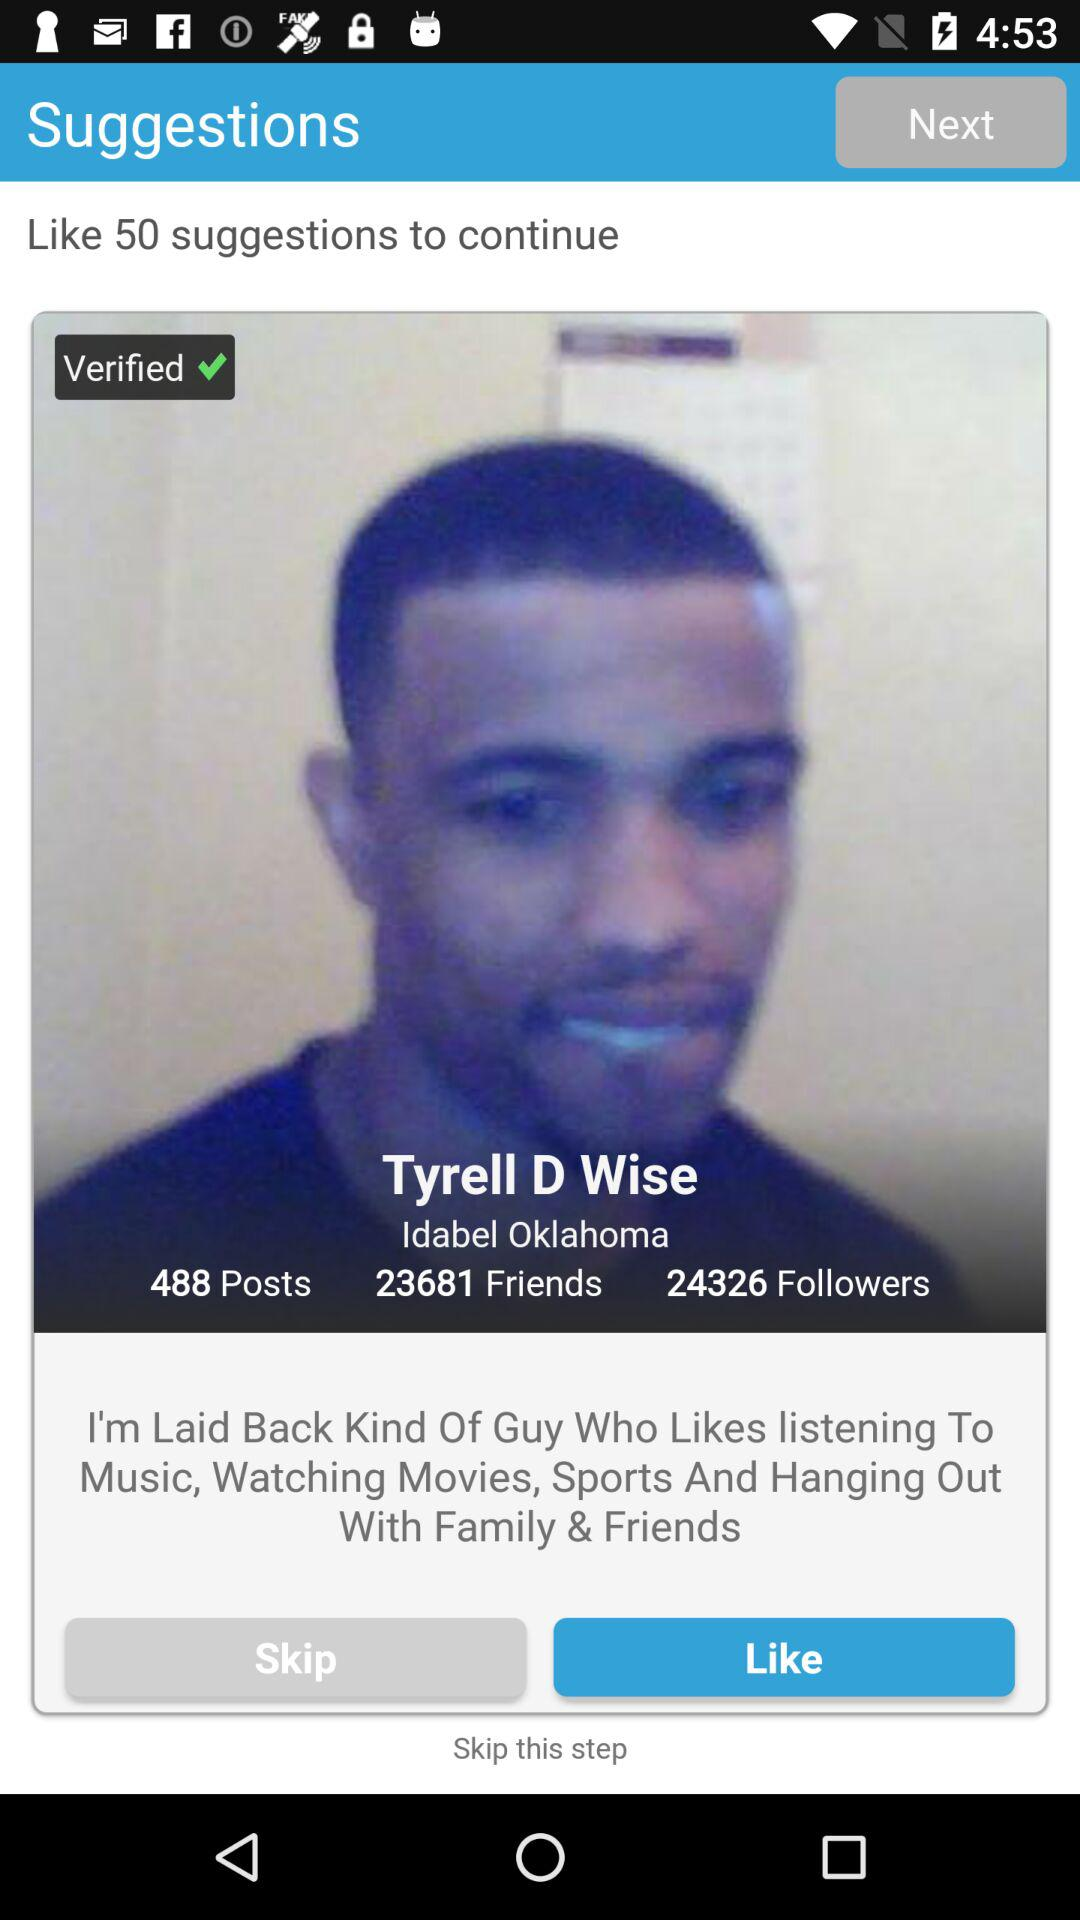How many friends does Tyrell D Wise have? Tyrell D. Wise have 23681 friends. 